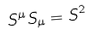<formula> <loc_0><loc_0><loc_500><loc_500>S ^ { \mu } S _ { \mu } = S ^ { 2 }</formula> 